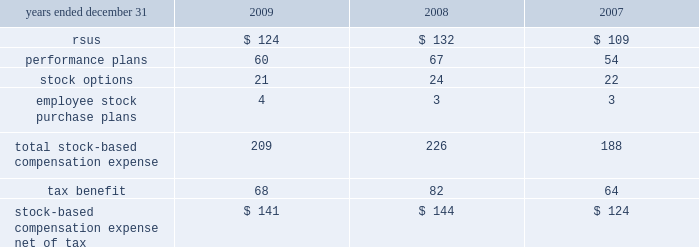14 .
Stock compensation plans the table summarizes stock-based compensation expense recognized in continuing operations in the consolidated statements of income in compensation and benefits ( in millions ) : .
During 2009 , the company converted its stock administration system to a new service provider .
In connection with this conversion , a reconciliation of the methodologies and estimates utilized was performed , which resulted in a $ 12 million reduction of expense for the year ended december 31 , 2009 .
Stock awards stock awards , in the form of rsus , are granted to certain employees and consist of both performance-based and service-based rsus .
Service-based awards generally vest between three and ten years from the date of grant .
The fair value of service-based awards is based upon the market price of the underlying common stock at the date of grant .
With certain limited exceptions , any break in continuous employment will cause the forfeiture of all unvested awards .
Compensation expense associated with stock awards is recognized over the service period using the straight-line method .
Dividend equivalents are paid on certain service-based rsus , based on the initial grant amount .
At december 31 , 2009 , 2008 and 2007 , the number of shares available for stock awards is included with options available for grant .
Performance-based rsus have been granted to certain employees .
Vesting of these awards is contingent upon meeting various individual , divisional or company-wide performance conditions , including revenue generation or growth in revenue , pretax income or earnings per share over a one- to five-year period .
The performance conditions are not considered in the determination of the grant date fair value for these awards .
The fair value of performance-based awards is based upon the market price of the underlying common stock at the date of grant .
Compensation expense is recognized over the performance period , and in certain cases an additional vesting period , based on management 2019s estimate of the number of units expected to vest .
Compensation expense is adjusted to reflect the actual number of shares paid out at the end of the programs .
The payout of shares under these performance-based plans may range from 0-200% ( 0-200 % ) of the number of units granted , based on the plan .
Dividend equivalents are generally not paid on the performance-based rsus .
During 2009 , the company granted approximately 2 million shares in connection with the completion of the 2006 leadership performance plan ( 2018 2018lpp 2019 2019 ) cycle .
During 2009 , 2008 and 2007 , the company granted approximately 3.7 million , 4.2 million and 4.3 million restricted shares , respectively , in connection with the company 2019s incentive compensation plans. .
What is the highest income from performance plans? 
Rationale: it is the maximum value .
Computations: table_max(performance plans, none)
Answer: 67.0. 